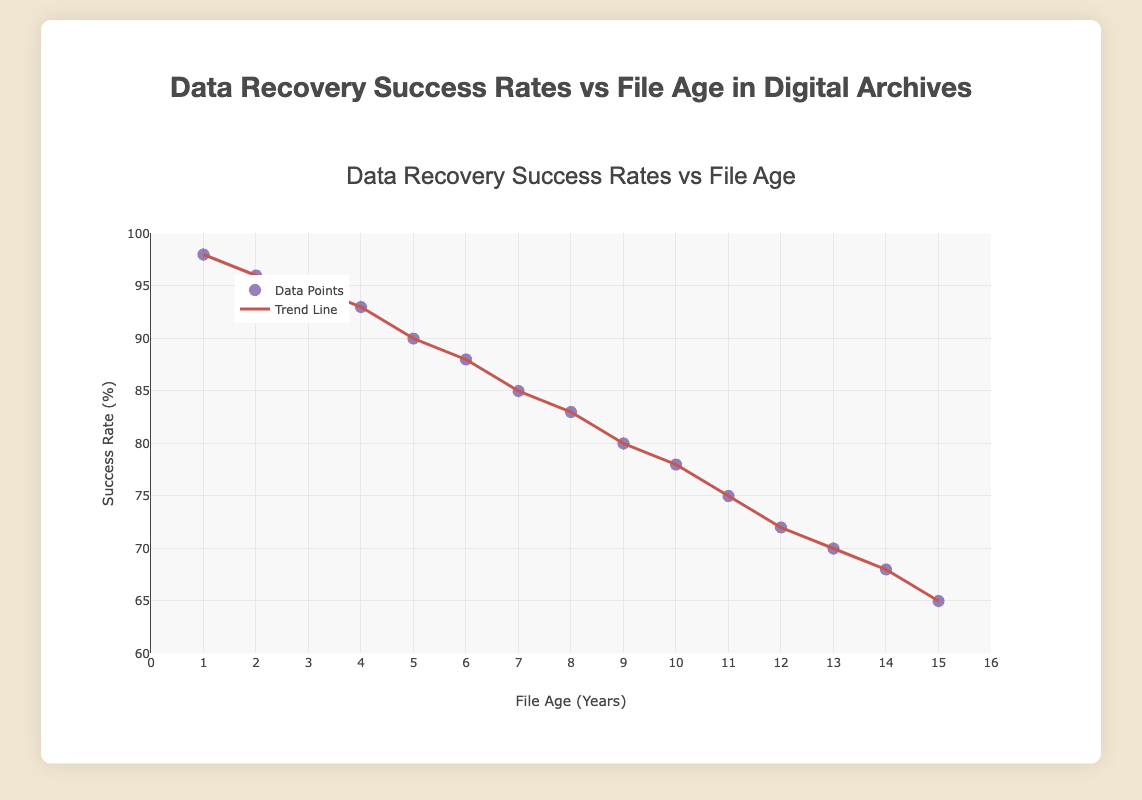What is the title of the plot? The plot title is displayed at the top center of the figure and is "Data Recovery Success Rates vs File Age".
Answer: Data Recovery Success Rates vs File Age What is the success rate for files aged 10 years? Look at the data point corresponding to 10 years on the x-axis and find the y-axis value, which is 78%.
Answer: 78% How many data points are displayed in the plot? Each file age from 1 to 15 years has a data point, counted by the number of file ages on the x-axis.
Answer: 15 What is the general trend of the data recovery success rate as file age increases? Observe the trend line, which shows a downward slope indicating that the success rate generally decreases as file age increases.
Answer: Decreases Which file age has the highest data recovery success rate and what is that rate? The first point on the x-axis (1 year) corresponds to the highest value on the y-axis, which is 98%.
Answer: 1 year, 98% What is the approximate success rate for files aged 7 years? Locate the point corresponding to 7 years on the x-axis and find its y-axis value, which is approximately 85%.
Answer: 85% How does the success rate for files aged 5 years compare to that for files aged 12 years? Find the success rates for file ages 5 years and 12 years on the y-axis, which are 90% and 72% respectively. The success rate for files aged 5 years is higher.
Answer: 5 years is higher What is the trend line's impact on interpreting the data recovery rates? The trend line helps illustrate the overall declining trend of success rates as file age increases, smoothing out individual data point variations.
Answer: Shows an overall decline What is the range of the y-axis? The y-axis starts at 60% and goes up to 100%, clearly labeled on the axis.
Answer: 60% to 100% What is the difference in success rate between files aged 2 years and files aged 14 years? Find the success rates for 2 years (96%) and 14 years (68%), then calculate the difference, which is 96% - 68% = 28%.
Answer: 28% 